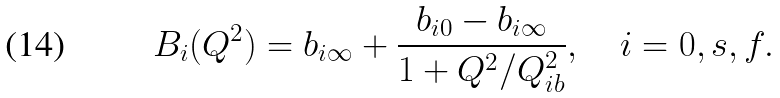<formula> <loc_0><loc_0><loc_500><loc_500>B _ { i } ( Q ^ { 2 } ) = b _ { i \infty } + \frac { b _ { i 0 } - b _ { i \infty } } { 1 + Q ^ { 2 } / Q ^ { 2 } _ { i b } } , \quad i = 0 , s , f .</formula> 